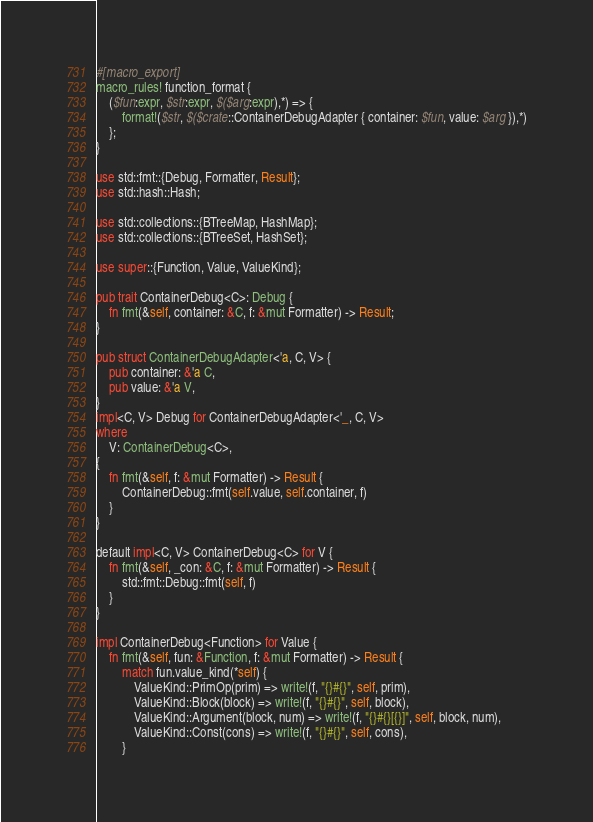<code> <loc_0><loc_0><loc_500><loc_500><_Rust_>#[macro_export]
macro_rules! function_format {
    ($fun:expr, $str:expr, $($arg:expr),*) => {
        format!($str, $($crate::ContainerDebugAdapter { container: $fun, value: $arg }),*)
    };
}

use std::fmt::{Debug, Formatter, Result};
use std::hash::Hash;

use std::collections::{BTreeMap, HashMap};
use std::collections::{BTreeSet, HashSet};

use super::{Function, Value, ValueKind};

pub trait ContainerDebug<C>: Debug {
    fn fmt(&self, container: &C, f: &mut Formatter) -> Result;
}

pub struct ContainerDebugAdapter<'a, C, V> {
    pub container: &'a C,
    pub value: &'a V,
}
impl<C, V> Debug for ContainerDebugAdapter<'_, C, V>
where
    V: ContainerDebug<C>,
{
    fn fmt(&self, f: &mut Formatter) -> Result {
        ContainerDebug::fmt(self.value, self.container, f)
    }
}

default impl<C, V> ContainerDebug<C> for V {
    fn fmt(&self, _con: &C, f: &mut Formatter) -> Result {
        std::fmt::Debug::fmt(self, f)
    }
}

impl ContainerDebug<Function> for Value {
    fn fmt(&self, fun: &Function, f: &mut Formatter) -> Result {
        match fun.value_kind(*self) {
            ValueKind::PrimOp(prim) => write!(f, "{}#{}", self, prim),
            ValueKind::Block(block) => write!(f, "{}#{}", self, block),
            ValueKind::Argument(block, num) => write!(f, "{}#{}[{}]", self, block, num),
            ValueKind::Const(cons) => write!(f, "{}#{}", self, cons),
        }</code> 